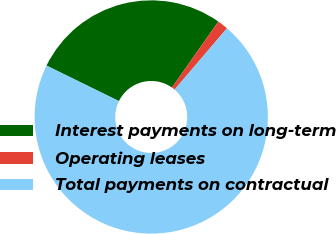<chart> <loc_0><loc_0><loc_500><loc_500><pie_chart><fcel>Interest payments on long-term<fcel>Operating leases<fcel>Total payments on contractual<nl><fcel>27.49%<fcel>1.5%<fcel>71.01%<nl></chart> 